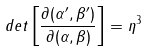<formula> <loc_0><loc_0><loc_500><loc_500>d e t \left [ \frac { \partial { ( \alpha ^ { \prime } , \beta ^ { \prime } ) } } { \partial { ( \alpha , \beta ) } } \right ] = \eta ^ { 3 }</formula> 